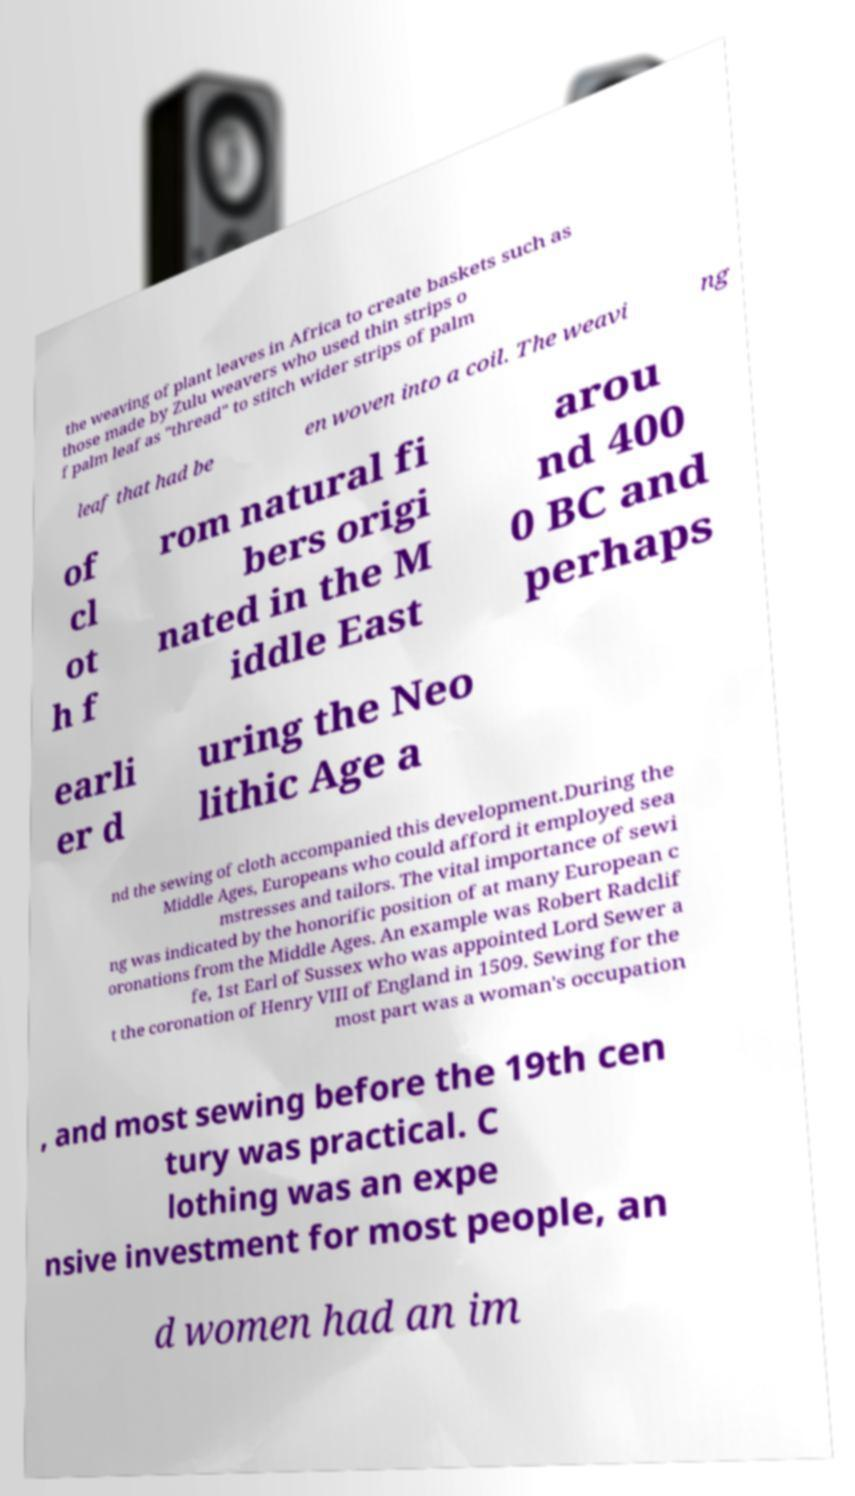There's text embedded in this image that I need extracted. Can you transcribe it verbatim? the weaving of plant leaves in Africa to create baskets such as those made by Zulu weavers who used thin strips o f palm leaf as "thread" to stitch wider strips of palm leaf that had be en woven into a coil. The weavi ng of cl ot h f rom natural fi bers origi nated in the M iddle East arou nd 400 0 BC and perhaps earli er d uring the Neo lithic Age a nd the sewing of cloth accompanied this development.During the Middle Ages, Europeans who could afford it employed sea mstresses and tailors. The vital importance of sewi ng was indicated by the honorific position of at many European c oronations from the Middle Ages. An example was Robert Radclif fe, 1st Earl of Sussex who was appointed Lord Sewer a t the coronation of Henry VIII of England in 1509. Sewing for the most part was a woman's occupation , and most sewing before the 19th cen tury was practical. C lothing was an expe nsive investment for most people, an d women had an im 